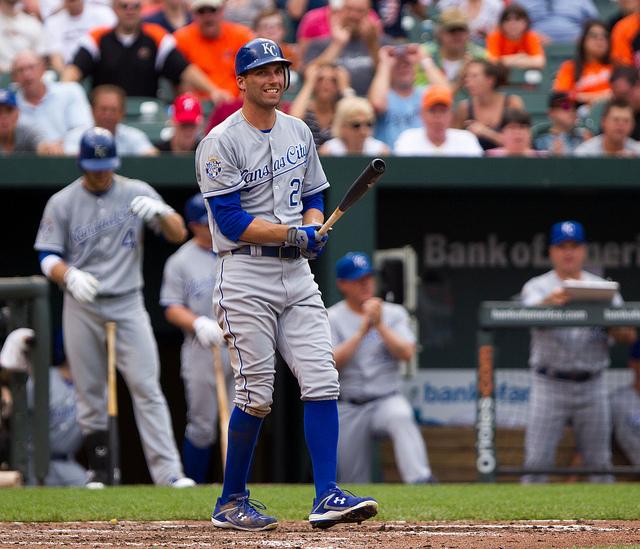What state does this team represent?
Short answer required. Kansas. What brand are the baseball player's shoes?
Concise answer only. Under armour. Why are the other players in the background?
Write a very short answer. Waiting. 